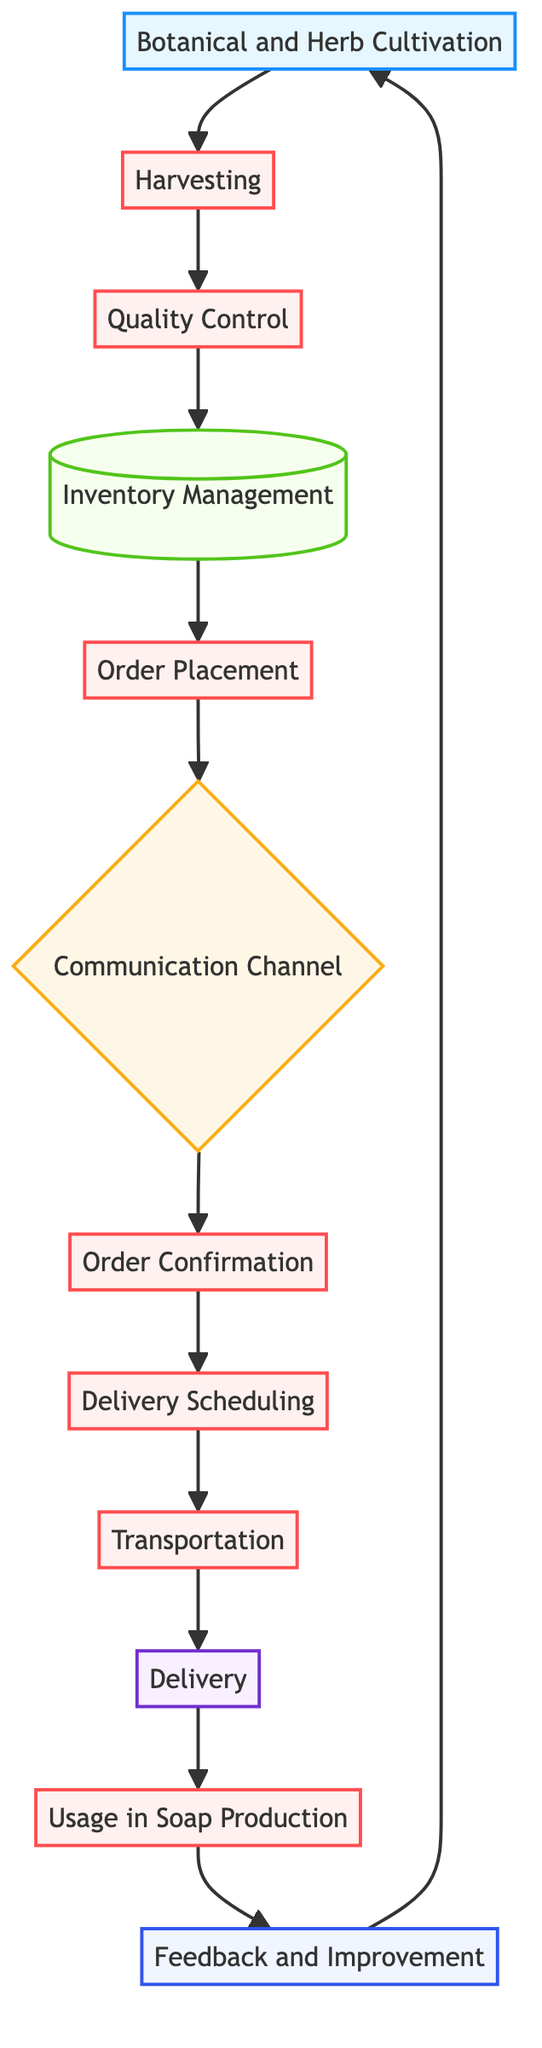What is the first process in the collaboration workflow? The first process in the diagram is "Harvesting," which directly follows "Botanical and Herb Cultivation."
Answer: Harvesting How many communication channels are identified in the diagram? The diagram specifies one communication channel which is the "Communication Channel" node.
Answer: One What happens after "Order Placement"? Following "Order Placement," the next step in the workflow is the "Communication Channel," where both parties discuss details regarding the order.
Answer: Communication Channel Which node has the output type? The output type node is "Delivery," which indicates the endpoint of the process where botanicals and herbs are delivered to the soap maker.
Answer: Delivery What is the final step in the feedback loop? The final step in the feedback loop is "Botanical and Herb Cultivation," where feedback and improvements discussed by the soap maker are considered for future cultivation.
Answer: Botanical and Herb Cultivation What is the relationship between "Usage in Soap Production" and "Feedback and Improvement"? The relationship is that "Usage in Soap Production" leads to "Feedback and Improvement," indicating that feedback is provided based on the usage of supplied botanicals and herbs.
Answer: Leads to How many processes are in the workflow? The diagram contains a total of six process nodes, including "Harvesting," "Quality Control," "Order Placement," "Order Confirmation," "Delivery Scheduling," and "Usage in Soap Production."
Answer: Six Which node indicates inventory management? The node that indicates inventory management is called "Inventory Management," where the farmer updates their inventory of botanicals and herbs available for orders.
Answer: Inventory Management How does the "Transportation" process relate to delivery? The "Transportation" process arranges the means to deliver the goods, and it is directly connected to the "Delivery" node, indicating it supports the delivery process.
Answer: Directly connected 